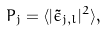Convert formula to latex. <formula><loc_0><loc_0><loc_500><loc_500>P _ { j } = \langle | \tilde { \epsilon } _ { j , l } | ^ { 2 } \rangle ,</formula> 